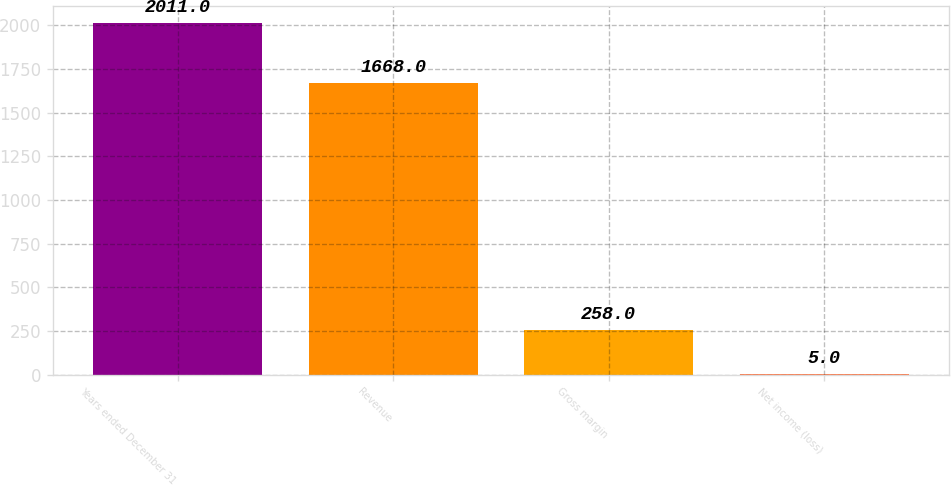Convert chart to OTSL. <chart><loc_0><loc_0><loc_500><loc_500><bar_chart><fcel>Years ended December 31<fcel>Revenue<fcel>Gross margin<fcel>Net income (loss)<nl><fcel>2011<fcel>1668<fcel>258<fcel>5<nl></chart> 